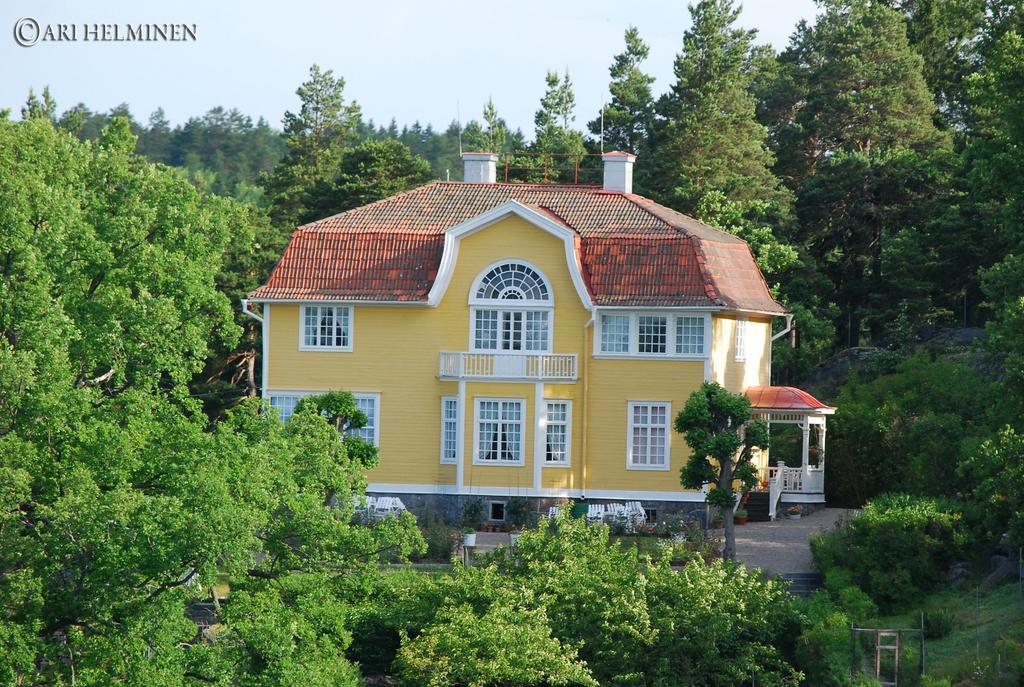Describe this image in one or two sentences. In the middle I can see a house. The background is covered with trees, text and the sky. This image is taken during a day. 